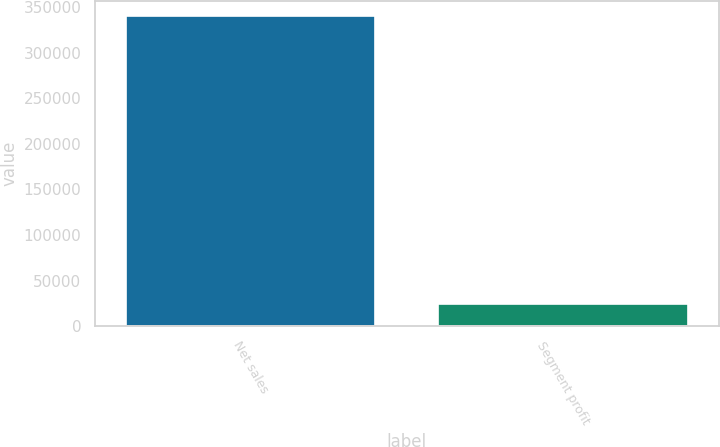<chart> <loc_0><loc_0><loc_500><loc_500><bar_chart><fcel>Net sales<fcel>Segment profit<nl><fcel>339807<fcel>24640<nl></chart> 